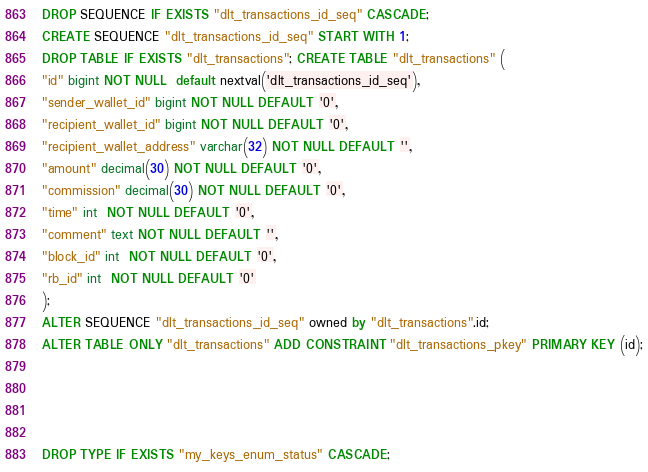Convert code to text. <code><loc_0><loc_0><loc_500><loc_500><_SQL_>DROP SEQUENCE IF EXISTS "dlt_transactions_id_seq" CASCADE;
CREATE SEQUENCE "dlt_transactions_id_seq" START WITH 1;
DROP TABLE IF EXISTS "dlt_transactions"; CREATE TABLE "dlt_transactions" (
"id" bigint NOT NULL  default nextval('dlt_transactions_id_seq'),
"sender_wallet_id" bigint NOT NULL DEFAULT '0',
"recipient_wallet_id" bigint NOT NULL DEFAULT '0',
"recipient_wallet_address" varchar(32) NOT NULL DEFAULT '',
"amount" decimal(30) NOT NULL DEFAULT '0',
"commission" decimal(30) NOT NULL DEFAULT '0',
"time" int  NOT NULL DEFAULT '0',
"comment" text NOT NULL DEFAULT '',
"block_id" int  NOT NULL DEFAULT '0',
"rb_id" int  NOT NULL DEFAULT '0'
);
ALTER SEQUENCE "dlt_transactions_id_seq" owned by "dlt_transactions".id;
ALTER TABLE ONLY "dlt_transactions" ADD CONSTRAINT "dlt_transactions_pkey" PRIMARY KEY (id);




DROP TYPE IF EXISTS "my_keys_enum_status" CASCADE;</code> 